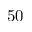Convert formula to latex. <formula><loc_0><loc_0><loc_500><loc_500>5 0</formula> 